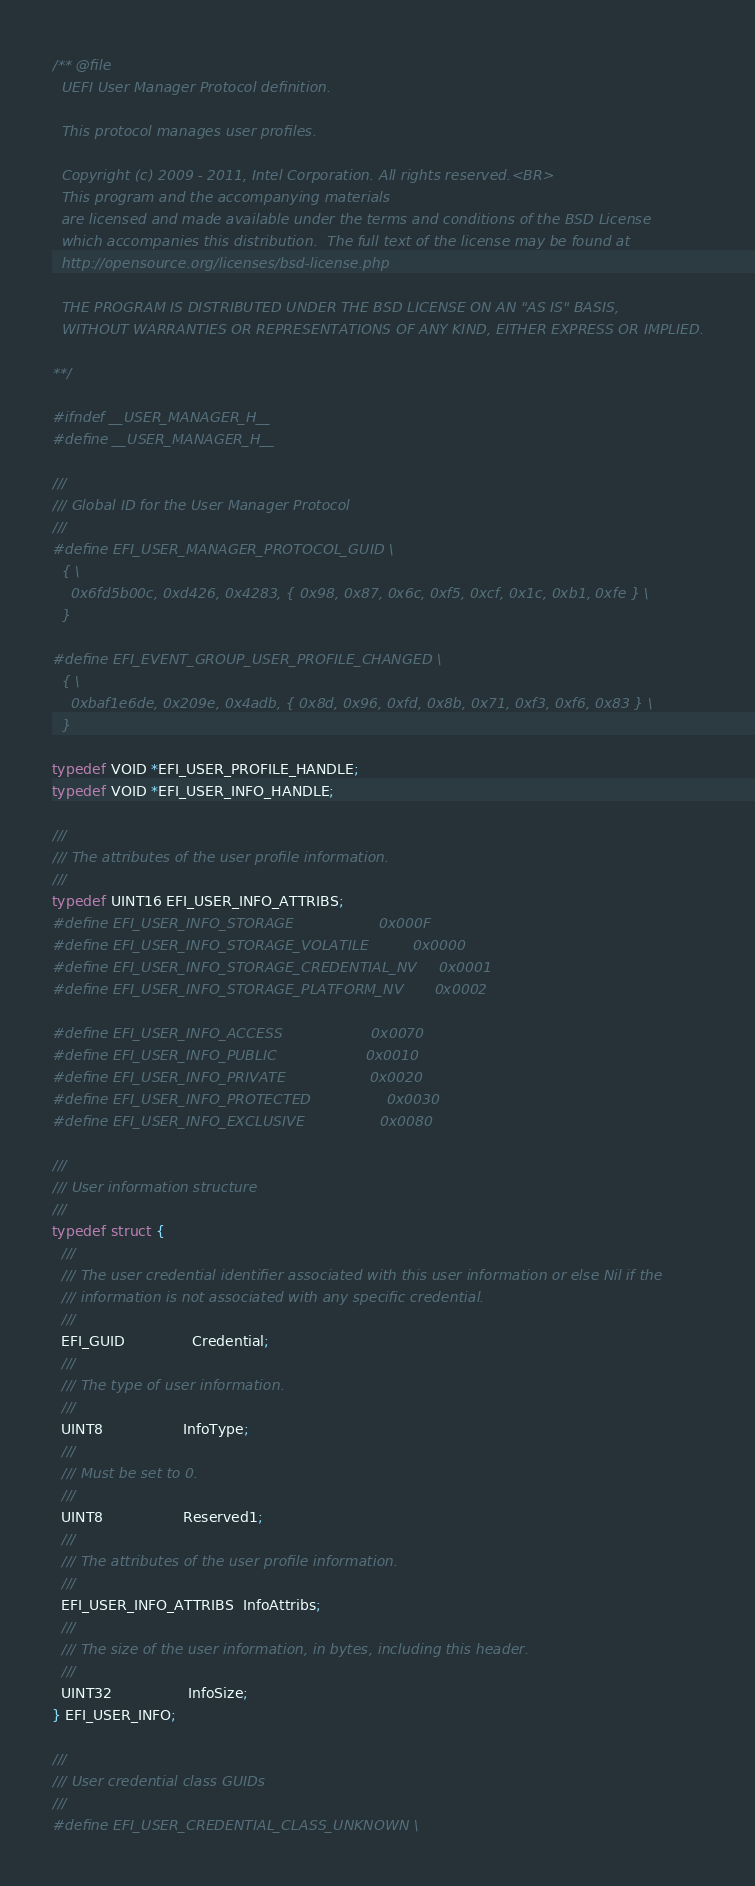<code> <loc_0><loc_0><loc_500><loc_500><_C_>/** @file
  UEFI User Manager Protocol definition.

  This protocol manages user profiles.

  Copyright (c) 2009 - 2011, Intel Corporation. All rights reserved.<BR>
  This program and the accompanying materials
  are licensed and made available under the terms and conditions of the BSD License
  which accompanies this distribution.  The full text of the license may be found at
  http://opensource.org/licenses/bsd-license.php

  THE PROGRAM IS DISTRIBUTED UNDER THE BSD LICENSE ON AN "AS IS" BASIS,
  WITHOUT WARRANTIES OR REPRESENTATIONS OF ANY KIND, EITHER EXPRESS OR IMPLIED.

**/

#ifndef __USER_MANAGER_H__
#define __USER_MANAGER_H__

///
/// Global ID for the User Manager Protocol
///
#define EFI_USER_MANAGER_PROTOCOL_GUID \
  { \
    0x6fd5b00c, 0xd426, 0x4283, { 0x98, 0x87, 0x6c, 0xf5, 0xcf, 0x1c, 0xb1, 0xfe } \
  }

#define EFI_EVENT_GROUP_USER_PROFILE_CHANGED \
  { \
    0xbaf1e6de, 0x209e, 0x4adb, { 0x8d, 0x96, 0xfd, 0x8b, 0x71, 0xf3, 0xf6, 0x83 } \
  }

typedef VOID *EFI_USER_PROFILE_HANDLE;
typedef VOID *EFI_USER_INFO_HANDLE;

///
/// The attributes of the user profile information.
///
typedef UINT16 EFI_USER_INFO_ATTRIBS;
#define EFI_USER_INFO_STORAGE                   0x000F
#define EFI_USER_INFO_STORAGE_VOLATILE          0x0000
#define EFI_USER_INFO_STORAGE_CREDENTIAL_NV     0x0001
#define EFI_USER_INFO_STORAGE_PLATFORM_NV       0x0002

#define EFI_USER_INFO_ACCESS                    0x0070
#define EFI_USER_INFO_PUBLIC                    0x0010
#define EFI_USER_INFO_PRIVATE                   0x0020
#define EFI_USER_INFO_PROTECTED                 0x0030
#define EFI_USER_INFO_EXCLUSIVE                 0x0080

///
/// User information structure
///
typedef struct {
  ///
  /// The user credential identifier associated with this user information or else Nil if the
  /// information is not associated with any specific credential.
  ///
  EFI_GUID               Credential;
  ///
  /// The type of user information.
  ///
  UINT8                  InfoType;
  ///
  /// Must be set to 0.
  ///
  UINT8                  Reserved1;
  ///
  /// The attributes of the user profile information.
  ///
  EFI_USER_INFO_ATTRIBS  InfoAttribs;
  ///
  /// The size of the user information, in bytes, including this header.
  ///
  UINT32                 InfoSize;
} EFI_USER_INFO;

///
/// User credential class GUIDs
///
#define EFI_USER_CREDENTIAL_CLASS_UNKNOWN \</code> 